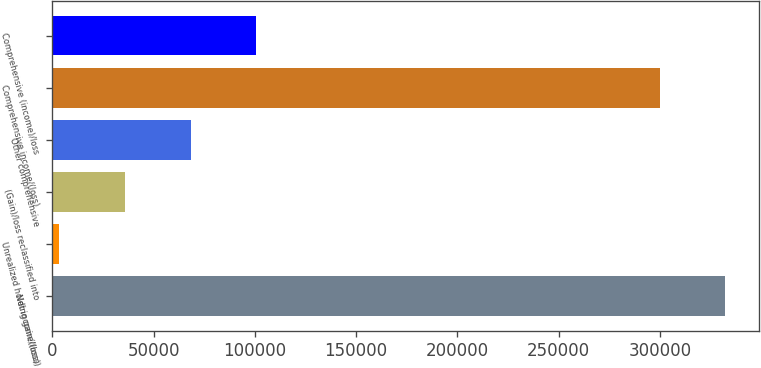Convert chart to OTSL. <chart><loc_0><loc_0><loc_500><loc_500><bar_chart><fcel>Net income/(loss)<fcel>Unrealized holding gain/(loss)<fcel>(Gain)/loss reclassified into<fcel>Other comprehensive<fcel>Comprehensive income/(loss)<fcel>Comprehensive (income)/loss<nl><fcel>332191<fcel>3514<fcel>35917.7<fcel>68321.4<fcel>299787<fcel>100725<nl></chart> 